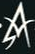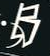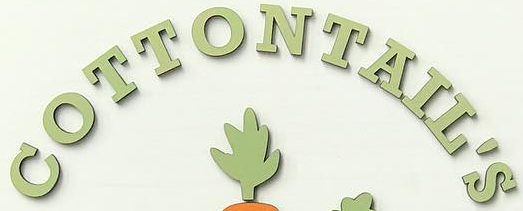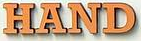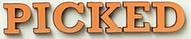Read the text from these images in sequence, separated by a semicolon. A; B; COTTONTAIL'S; HAND; PICKED 